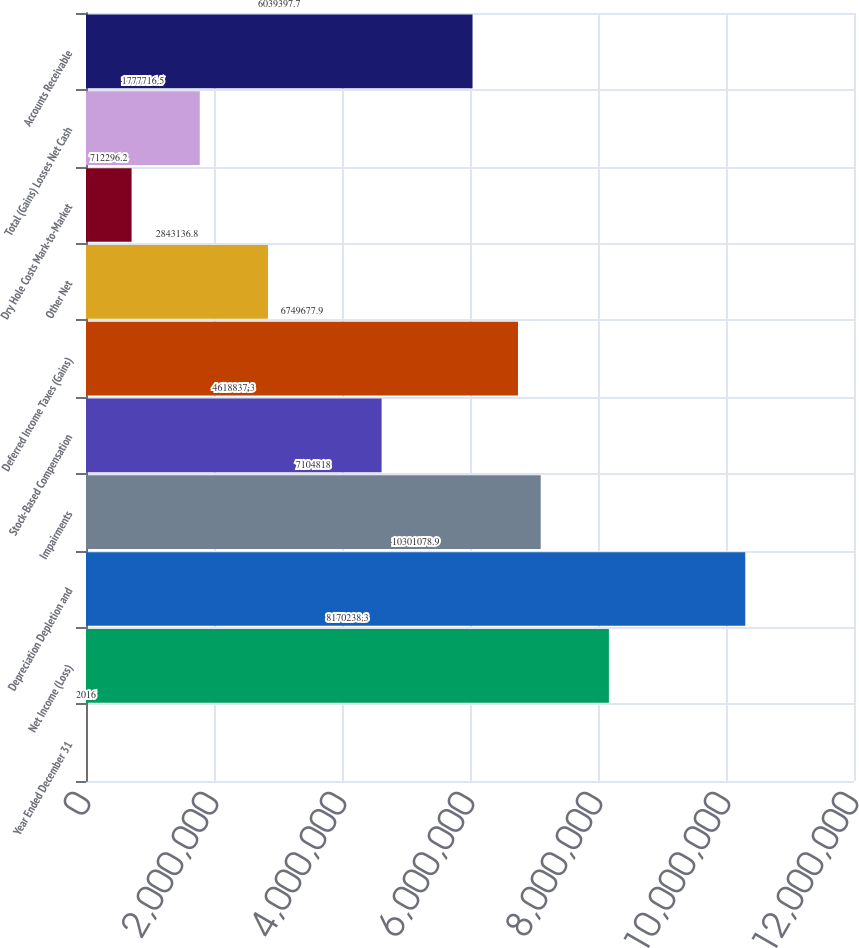Convert chart to OTSL. <chart><loc_0><loc_0><loc_500><loc_500><bar_chart><fcel>Year Ended December 31<fcel>Net Income (Loss)<fcel>Depreciation Depletion and<fcel>Impairments<fcel>Stock-Based Compensation<fcel>Deferred Income Taxes (Gains)<fcel>Other Net<fcel>Dry Hole Costs Mark-to-Market<fcel>Total (Gains) Losses Net Cash<fcel>Accounts Receivable<nl><fcel>2016<fcel>8.17024e+06<fcel>1.03011e+07<fcel>7.10482e+06<fcel>4.61884e+06<fcel>6.74968e+06<fcel>2.84314e+06<fcel>712296<fcel>1.77772e+06<fcel>6.0394e+06<nl></chart> 